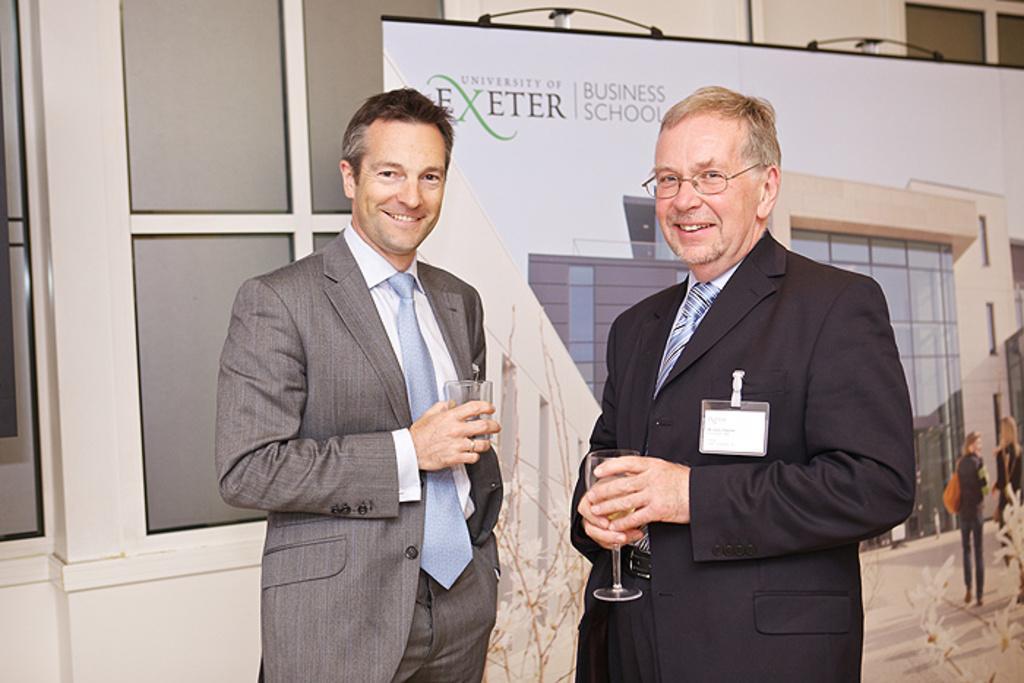Describe this image in one or two sentences. In this image there are two people standing by holding a glass of drink in their hand are posing for the camera with a smile on their face, behind them there is a poster, behind the poster there is a wall. 